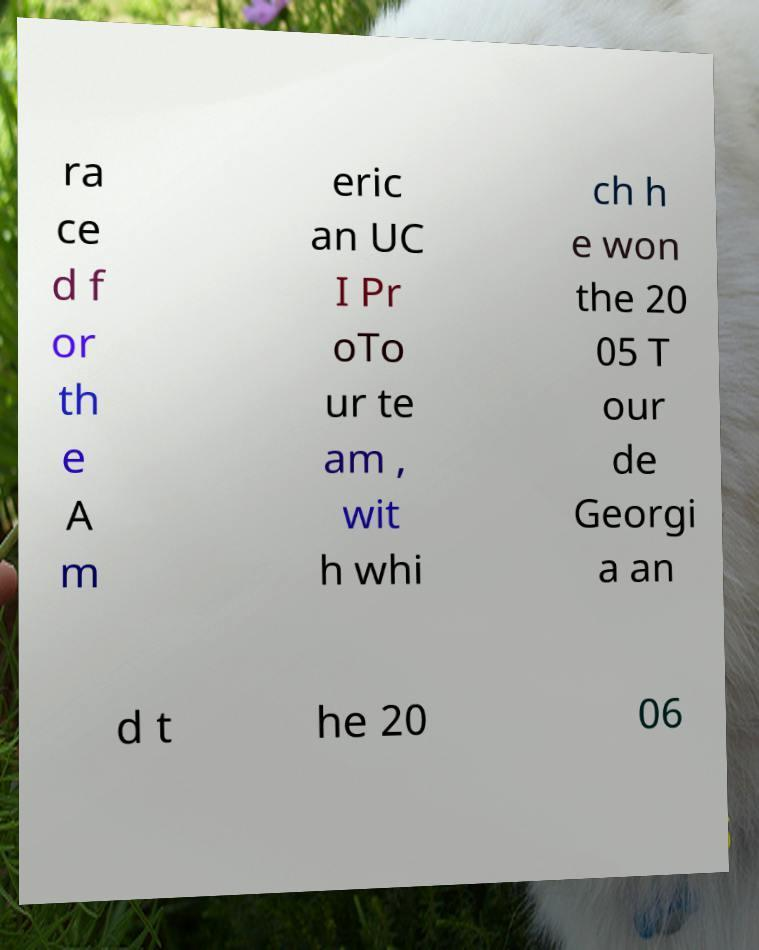For documentation purposes, I need the text within this image transcribed. Could you provide that? ra ce d f or th e A m eric an UC I Pr oTo ur te am , wit h whi ch h e won the 20 05 T our de Georgi a an d t he 20 06 